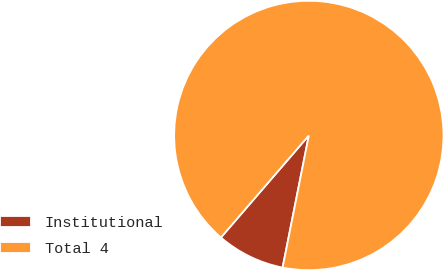<chart> <loc_0><loc_0><loc_500><loc_500><pie_chart><fcel>Institutional<fcel>Total 4<nl><fcel>8.2%<fcel>91.8%<nl></chart> 